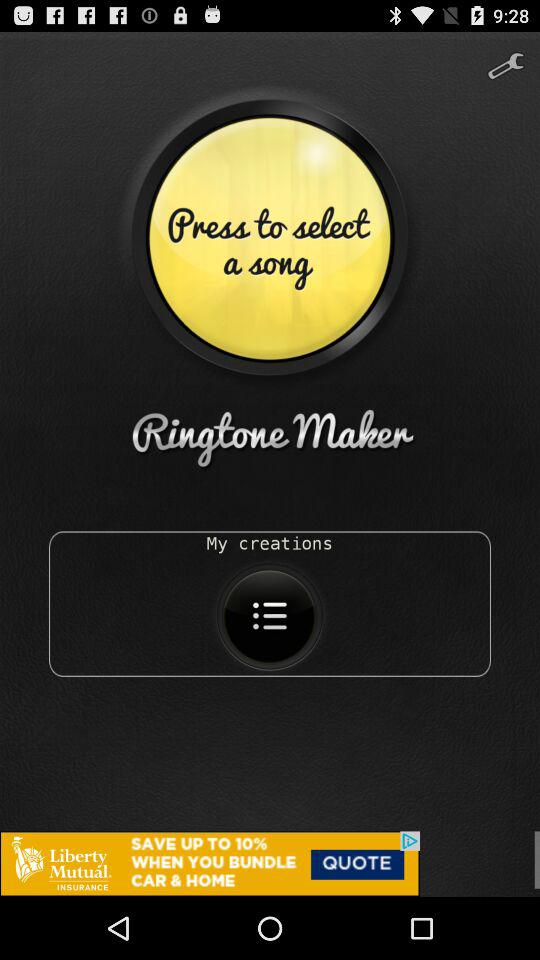Which song is selected?
When the provided information is insufficient, respond with <no answer>. <no answer> 